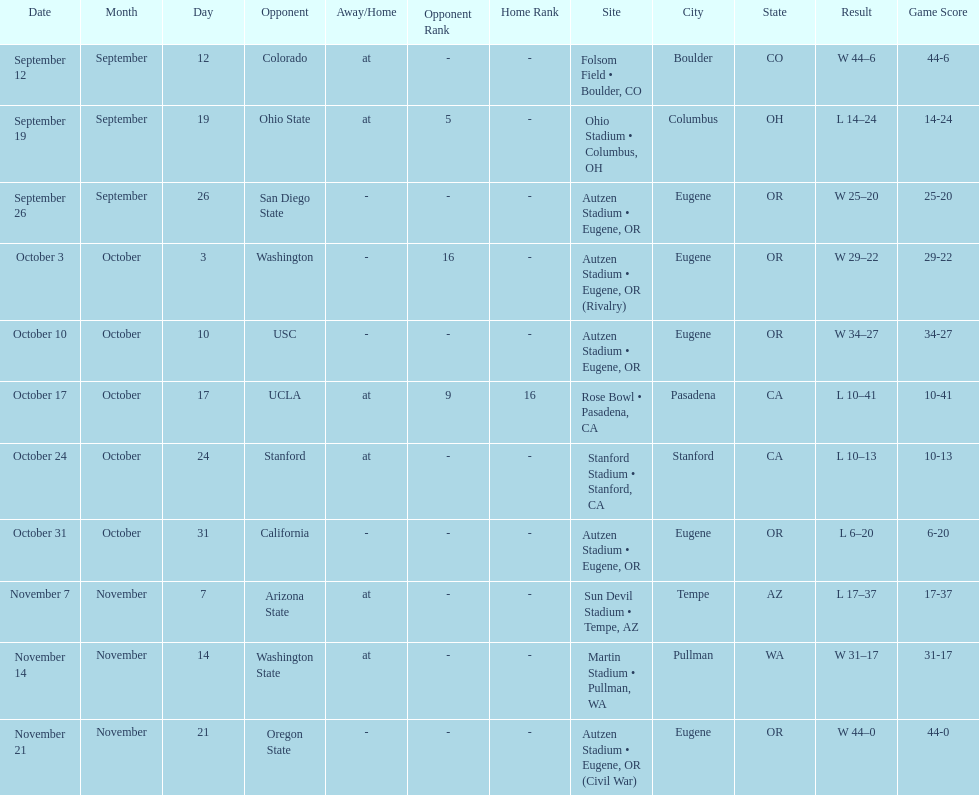How many wins are listed for the season? 6. 